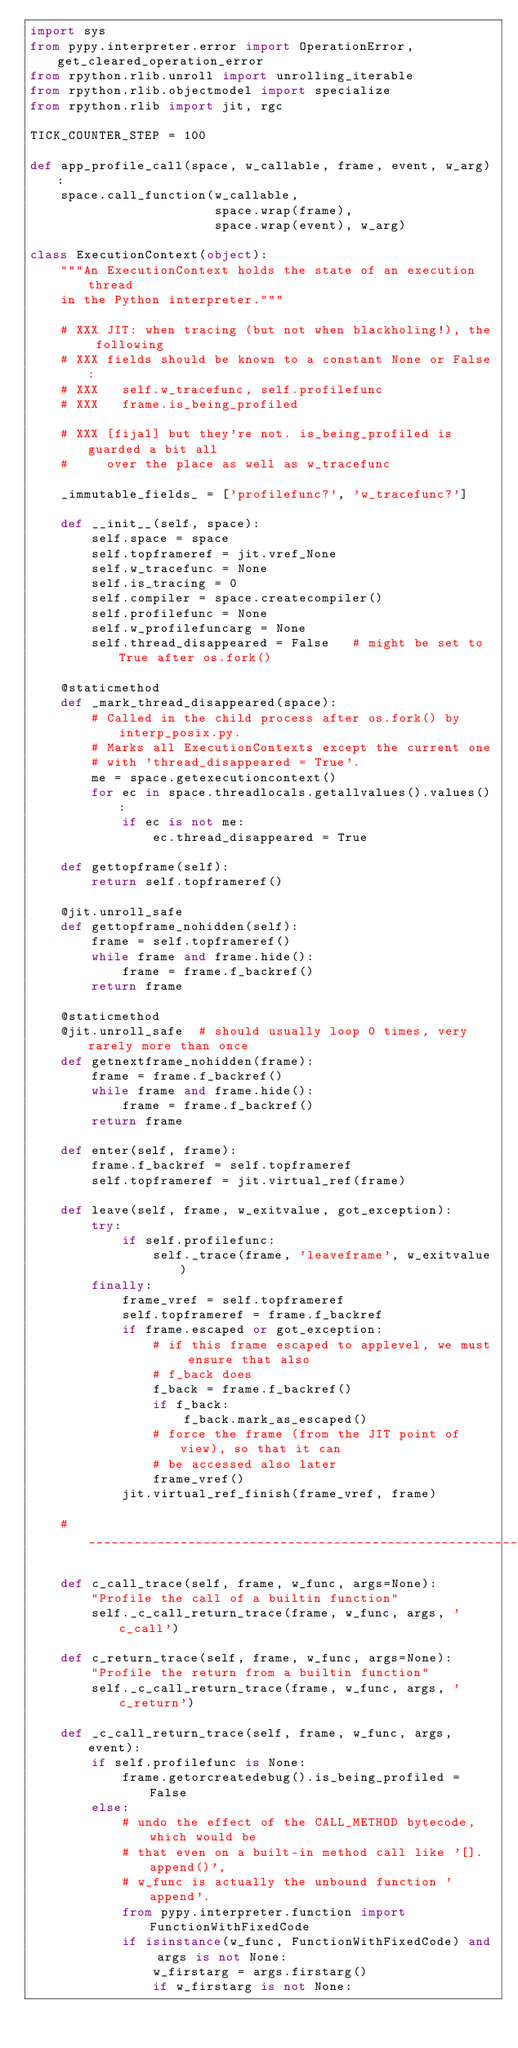<code> <loc_0><loc_0><loc_500><loc_500><_Python_>import sys
from pypy.interpreter.error import OperationError, get_cleared_operation_error
from rpython.rlib.unroll import unrolling_iterable
from rpython.rlib.objectmodel import specialize
from rpython.rlib import jit, rgc

TICK_COUNTER_STEP = 100

def app_profile_call(space, w_callable, frame, event, w_arg):
    space.call_function(w_callable,
                        space.wrap(frame),
                        space.wrap(event), w_arg)

class ExecutionContext(object):
    """An ExecutionContext holds the state of an execution thread
    in the Python interpreter."""

    # XXX JIT: when tracing (but not when blackholing!), the following
    # XXX fields should be known to a constant None or False:
    # XXX   self.w_tracefunc, self.profilefunc
    # XXX   frame.is_being_profiled

    # XXX [fijal] but they're not. is_being_profiled is guarded a bit all
    #     over the place as well as w_tracefunc

    _immutable_fields_ = ['profilefunc?', 'w_tracefunc?']

    def __init__(self, space):
        self.space = space
        self.topframeref = jit.vref_None
        self.w_tracefunc = None
        self.is_tracing = 0
        self.compiler = space.createcompiler()
        self.profilefunc = None
        self.w_profilefuncarg = None
        self.thread_disappeared = False   # might be set to True after os.fork()

    @staticmethod
    def _mark_thread_disappeared(space):
        # Called in the child process after os.fork() by interp_posix.py.
        # Marks all ExecutionContexts except the current one
        # with 'thread_disappeared = True'.
        me = space.getexecutioncontext()
        for ec in space.threadlocals.getallvalues().values():
            if ec is not me:
                ec.thread_disappeared = True

    def gettopframe(self):
        return self.topframeref()

    @jit.unroll_safe
    def gettopframe_nohidden(self):
        frame = self.topframeref()
        while frame and frame.hide():
            frame = frame.f_backref()
        return frame

    @staticmethod
    @jit.unroll_safe  # should usually loop 0 times, very rarely more than once
    def getnextframe_nohidden(frame):
        frame = frame.f_backref()
        while frame and frame.hide():
            frame = frame.f_backref()
        return frame

    def enter(self, frame):
        frame.f_backref = self.topframeref
        self.topframeref = jit.virtual_ref(frame)

    def leave(self, frame, w_exitvalue, got_exception):
        try:
            if self.profilefunc:
                self._trace(frame, 'leaveframe', w_exitvalue)
        finally:
            frame_vref = self.topframeref
            self.topframeref = frame.f_backref
            if frame.escaped or got_exception:
                # if this frame escaped to applevel, we must ensure that also
                # f_back does
                f_back = frame.f_backref()
                if f_back:
                    f_back.mark_as_escaped()
                # force the frame (from the JIT point of view), so that it can
                # be accessed also later
                frame_vref()
            jit.virtual_ref_finish(frame_vref, frame)

    # ________________________________________________________________

    def c_call_trace(self, frame, w_func, args=None):
        "Profile the call of a builtin function"
        self._c_call_return_trace(frame, w_func, args, 'c_call')

    def c_return_trace(self, frame, w_func, args=None):
        "Profile the return from a builtin function"
        self._c_call_return_trace(frame, w_func, args, 'c_return')

    def _c_call_return_trace(self, frame, w_func, args, event):
        if self.profilefunc is None:
            frame.getorcreatedebug().is_being_profiled = False
        else:
            # undo the effect of the CALL_METHOD bytecode, which would be
            # that even on a built-in method call like '[].append()',
            # w_func is actually the unbound function 'append'.
            from pypy.interpreter.function import FunctionWithFixedCode
            if isinstance(w_func, FunctionWithFixedCode) and args is not None:
                w_firstarg = args.firstarg()
                if w_firstarg is not None:</code> 